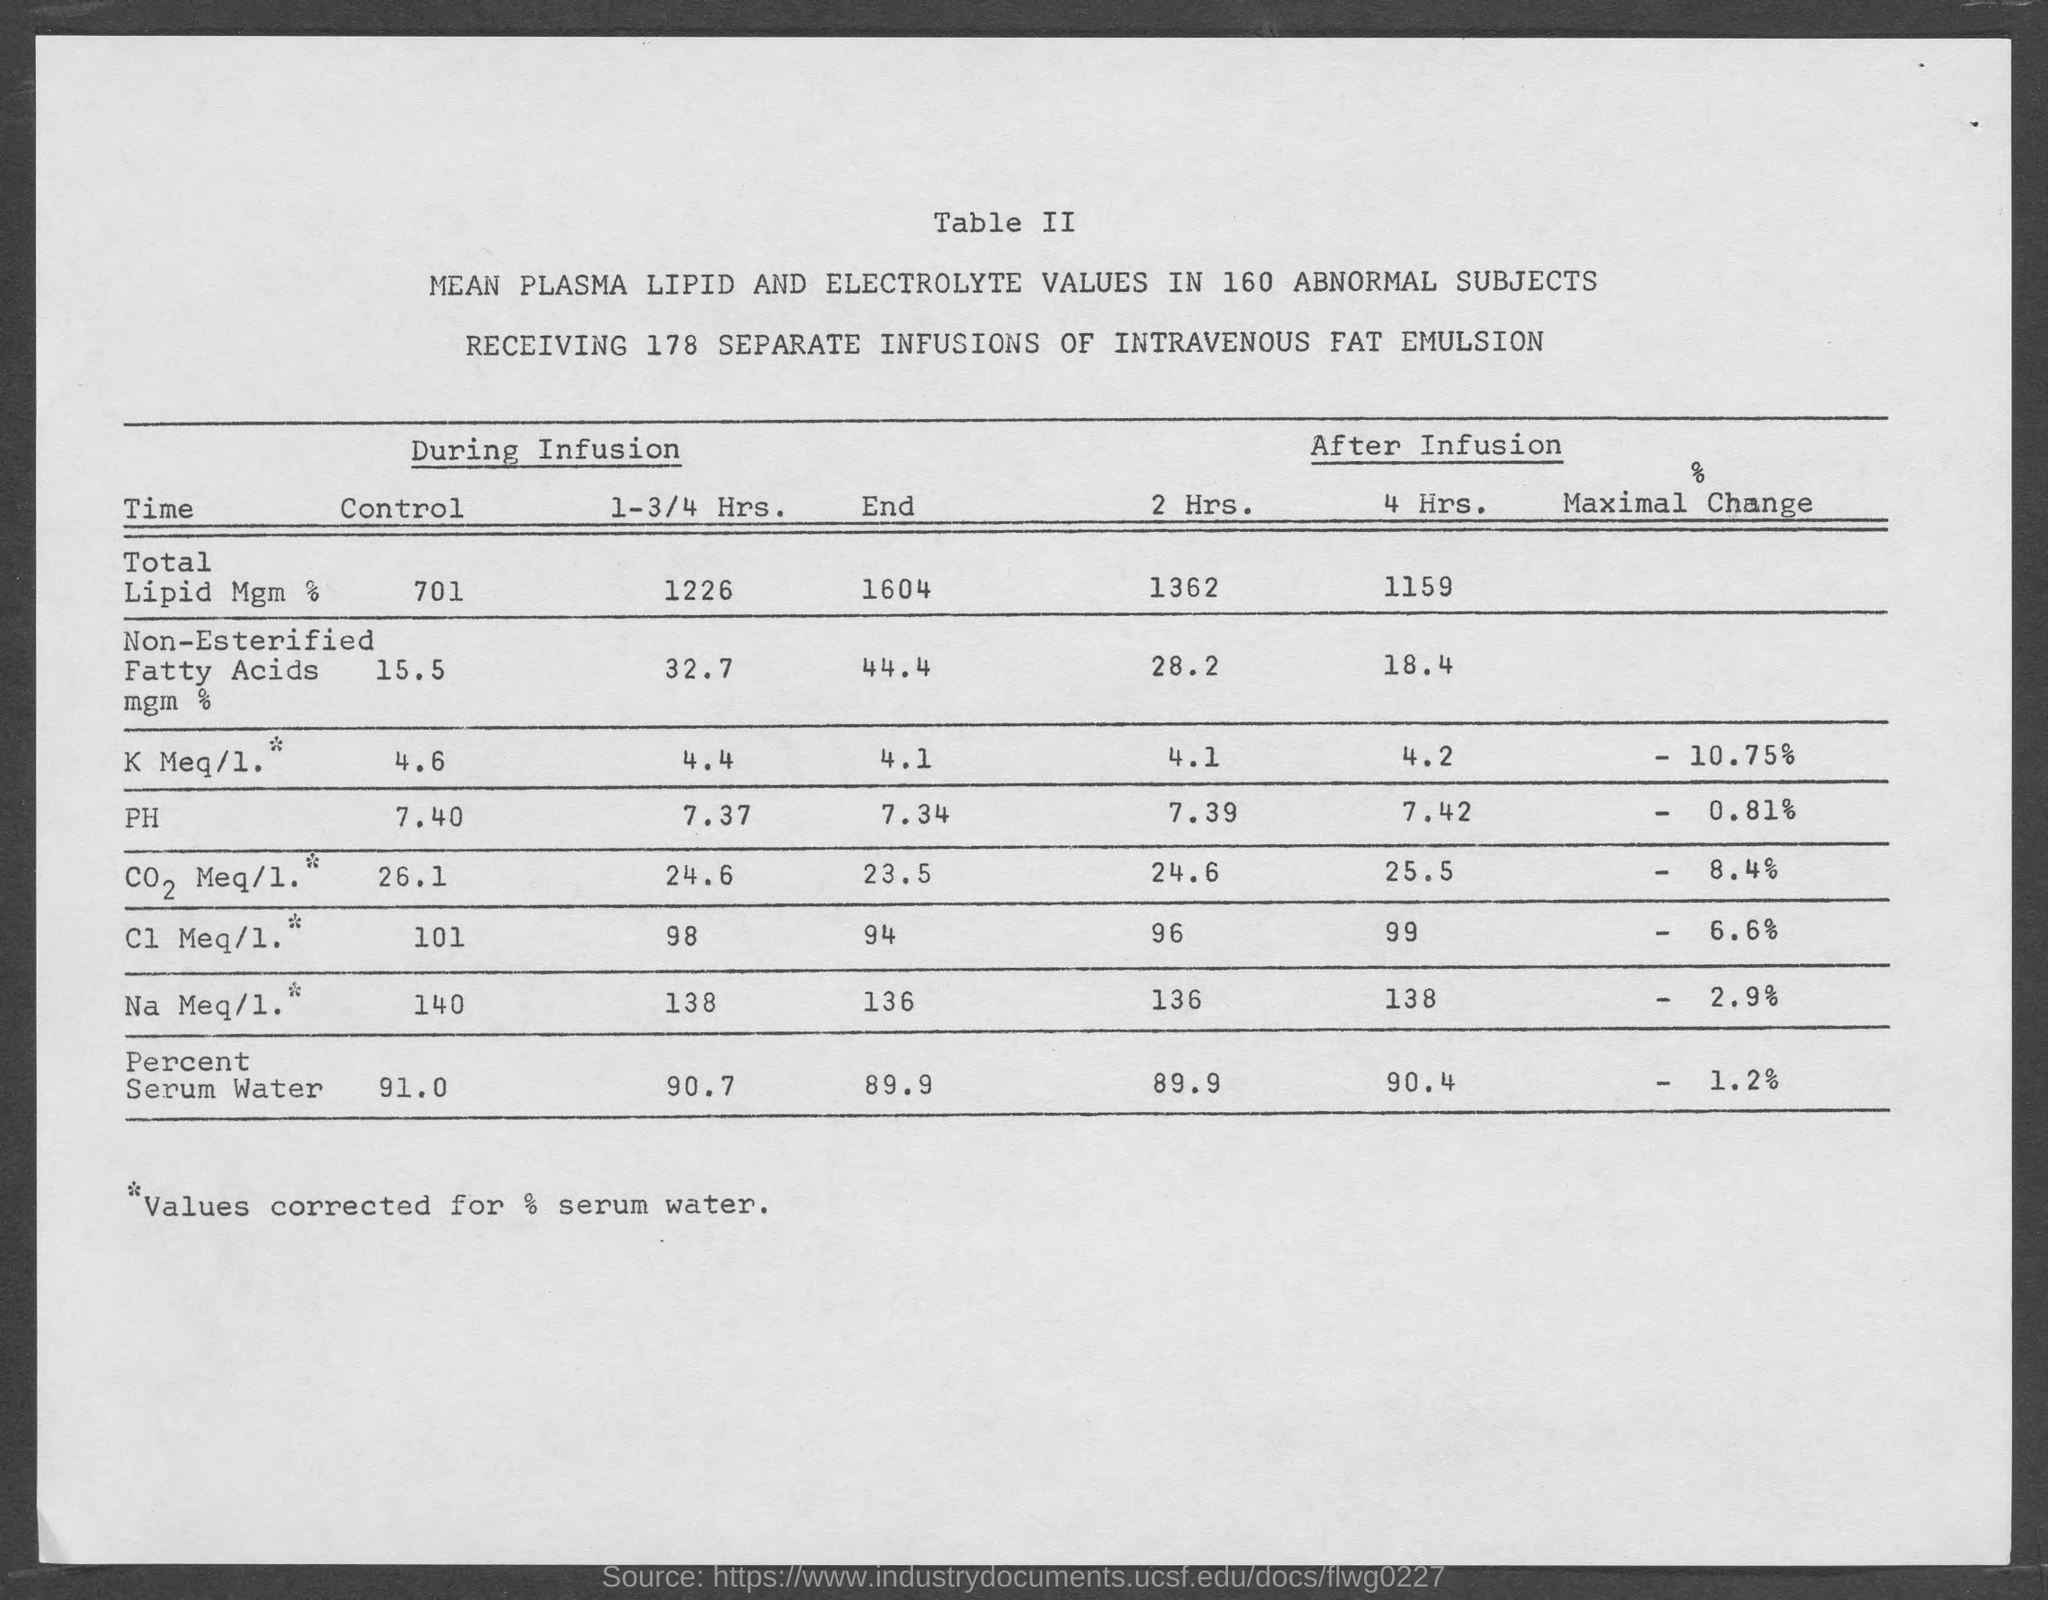List a handful of essential elements in this visual. A total of 178 separate infusions of intravenous fat emulsion have been administered. 